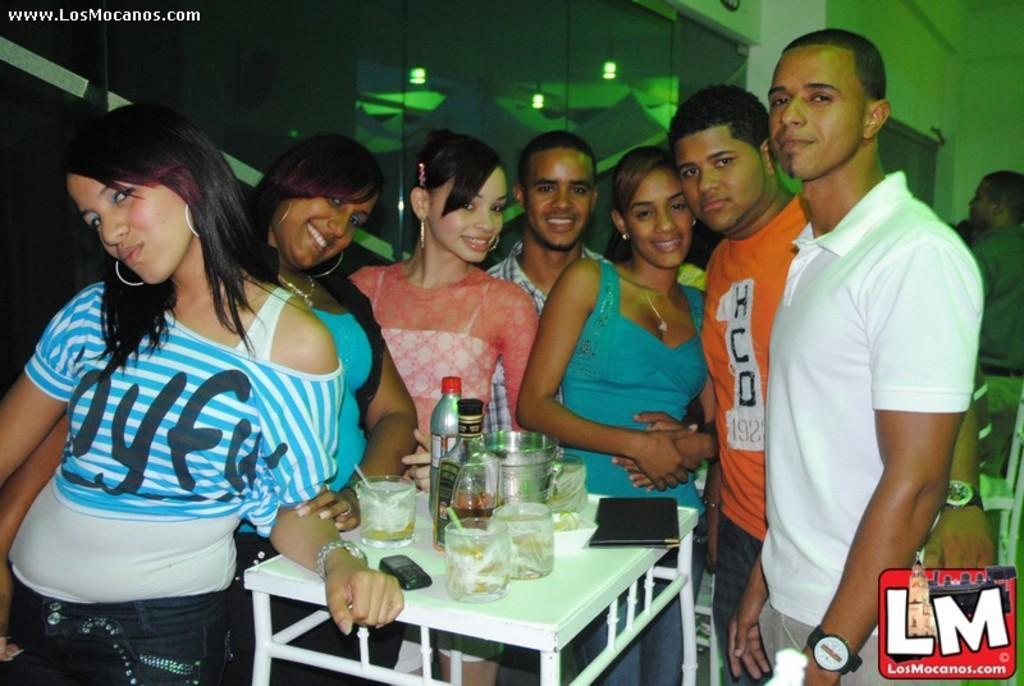Please provide a concise description of this image. There are few people here standing and giving pose to come. On the table we can see water bottle,glasses and wine bottle. 